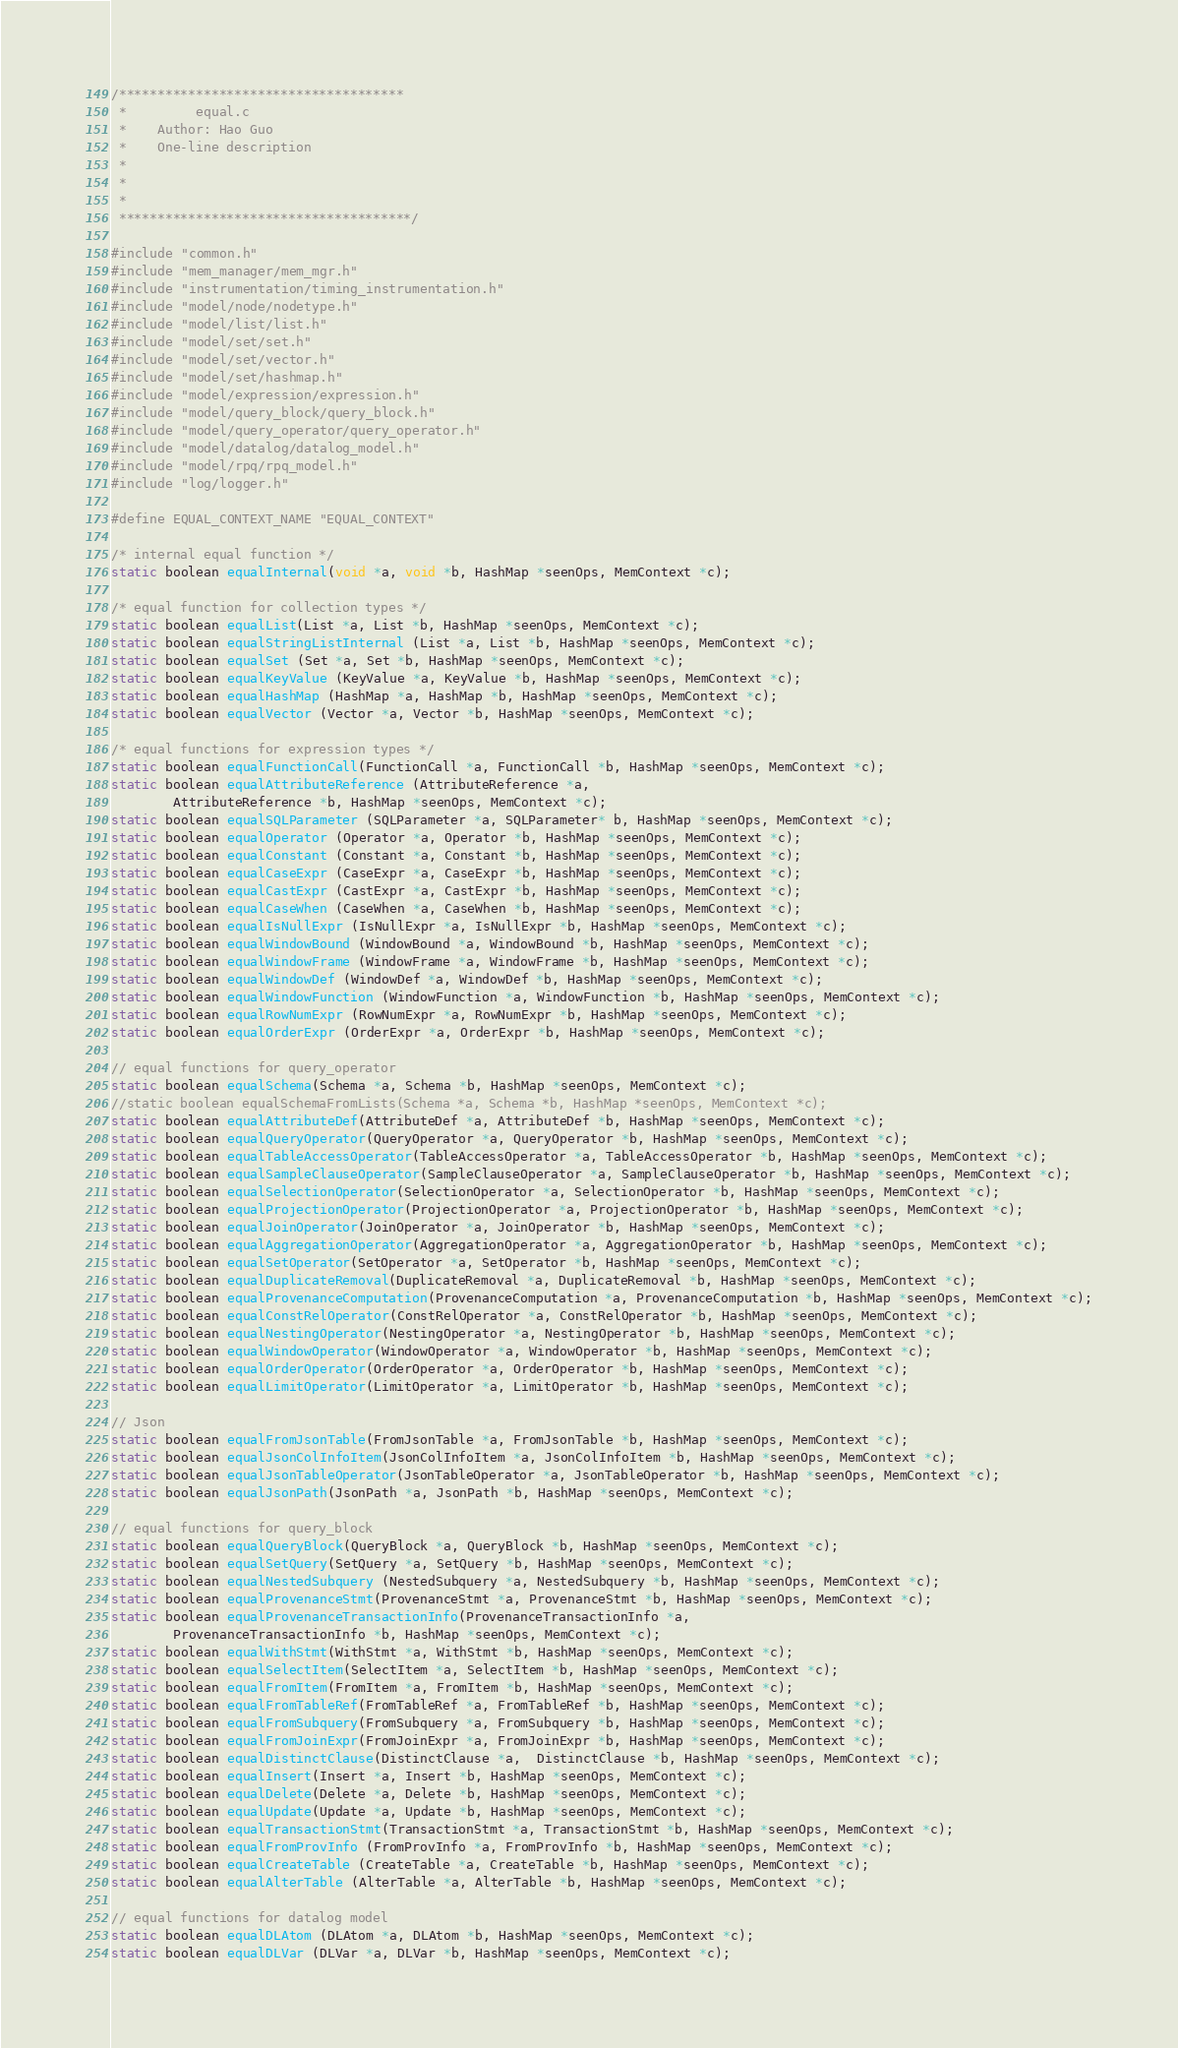Convert code to text. <code><loc_0><loc_0><loc_500><loc_500><_C_>/*************************************
 *         equal.c
 *    Author: Hao Guo
 *    One-line description
 *
 *
 *
 **************************************/

#include "common.h"
#include "mem_manager/mem_mgr.h"
#include "instrumentation/timing_instrumentation.h"
#include "model/node/nodetype.h"
#include "model/list/list.h"
#include "model/set/set.h"
#include "model/set/vector.h"
#include "model/set/hashmap.h"
#include "model/expression/expression.h"
#include "model/query_block/query_block.h"
#include "model/query_operator/query_operator.h"
#include "model/datalog/datalog_model.h"
#include "model/rpq/rpq_model.h"
#include "log/logger.h"

#define EQUAL_CONTEXT_NAME "EQUAL_CONTEXT"

/* internal equal function */
static boolean equalInternal(void *a, void *b, HashMap *seenOps, MemContext *c);

/* equal function for collection types */
static boolean equalList(List *a, List *b, HashMap *seenOps, MemContext *c);
static boolean equalStringListInternal (List *a, List *b, HashMap *seenOps, MemContext *c);
static boolean equalSet (Set *a, Set *b, HashMap *seenOps, MemContext *c);
static boolean equalKeyValue (KeyValue *a, KeyValue *b, HashMap *seenOps, MemContext *c);
static boolean equalHashMap (HashMap *a, HashMap *b, HashMap *seenOps, MemContext *c);
static boolean equalVector (Vector *a, Vector *b, HashMap *seenOps, MemContext *c);

/* equal functions for expression types */
static boolean equalFunctionCall(FunctionCall *a, FunctionCall *b, HashMap *seenOps, MemContext *c);
static boolean equalAttributeReference (AttributeReference *a,
        AttributeReference *b, HashMap *seenOps, MemContext *c);
static boolean equalSQLParameter (SQLParameter *a, SQLParameter* b, HashMap *seenOps, MemContext *c);
static boolean equalOperator (Operator *a, Operator *b, HashMap *seenOps, MemContext *c);
static boolean equalConstant (Constant *a, Constant *b, HashMap *seenOps, MemContext *c);
static boolean equalCaseExpr (CaseExpr *a, CaseExpr *b, HashMap *seenOps, MemContext *c);
static boolean equalCastExpr (CastExpr *a, CastExpr *b, HashMap *seenOps, MemContext *c);
static boolean equalCaseWhen (CaseWhen *a, CaseWhen *b, HashMap *seenOps, MemContext *c);
static boolean equalIsNullExpr (IsNullExpr *a, IsNullExpr *b, HashMap *seenOps, MemContext *c);
static boolean equalWindowBound (WindowBound *a, WindowBound *b, HashMap *seenOps, MemContext *c);
static boolean equalWindowFrame (WindowFrame *a, WindowFrame *b, HashMap *seenOps, MemContext *c);
static boolean equalWindowDef (WindowDef *a, WindowDef *b, HashMap *seenOps, MemContext *c);
static boolean equalWindowFunction (WindowFunction *a, WindowFunction *b, HashMap *seenOps, MemContext *c);
static boolean equalRowNumExpr (RowNumExpr *a, RowNumExpr *b, HashMap *seenOps, MemContext *c);
static boolean equalOrderExpr (OrderExpr *a, OrderExpr *b, HashMap *seenOps, MemContext *c);

// equal functions for query_operator
static boolean equalSchema(Schema *a, Schema *b, HashMap *seenOps, MemContext *c);
//static boolean equalSchemaFromLists(Schema *a, Schema *b, HashMap *seenOps, MemContext *c);
static boolean equalAttributeDef(AttributeDef *a, AttributeDef *b, HashMap *seenOps, MemContext *c);
static boolean equalQueryOperator(QueryOperator *a, QueryOperator *b, HashMap *seenOps, MemContext *c);
static boolean equalTableAccessOperator(TableAccessOperator *a, TableAccessOperator *b, HashMap *seenOps, MemContext *c);
static boolean equalSampleClauseOperator(SampleClauseOperator *a, SampleClauseOperator *b, HashMap *seenOps, MemContext *c);
static boolean equalSelectionOperator(SelectionOperator *a, SelectionOperator *b, HashMap *seenOps, MemContext *c);
static boolean equalProjectionOperator(ProjectionOperator *a, ProjectionOperator *b, HashMap *seenOps, MemContext *c);
static boolean equalJoinOperator(JoinOperator *a, JoinOperator *b, HashMap *seenOps, MemContext *c);
static boolean equalAggregationOperator(AggregationOperator *a, AggregationOperator *b, HashMap *seenOps, MemContext *c);
static boolean equalSetOperator(SetOperator *a, SetOperator *b, HashMap *seenOps, MemContext *c);
static boolean equalDuplicateRemoval(DuplicateRemoval *a, DuplicateRemoval *b, HashMap *seenOps, MemContext *c);
static boolean equalProvenanceComputation(ProvenanceComputation *a, ProvenanceComputation *b, HashMap *seenOps, MemContext *c);
static boolean equalConstRelOperator(ConstRelOperator *a, ConstRelOperator *b, HashMap *seenOps, MemContext *c);
static boolean equalNestingOperator(NestingOperator *a, NestingOperator *b, HashMap *seenOps, MemContext *c);
static boolean equalWindowOperator(WindowOperator *a, WindowOperator *b, HashMap *seenOps, MemContext *c);
static boolean equalOrderOperator(OrderOperator *a, OrderOperator *b, HashMap *seenOps, MemContext *c);
static boolean equalLimitOperator(LimitOperator *a, LimitOperator *b, HashMap *seenOps, MemContext *c);

// Json
static boolean equalFromJsonTable(FromJsonTable *a, FromJsonTable *b, HashMap *seenOps, MemContext *c);
static boolean equalJsonColInfoItem(JsonColInfoItem *a, JsonColInfoItem *b, HashMap *seenOps, MemContext *c);
static boolean equalJsonTableOperator(JsonTableOperator *a, JsonTableOperator *b, HashMap *seenOps, MemContext *c);
static boolean equalJsonPath(JsonPath *a, JsonPath *b, HashMap *seenOps, MemContext *c);

// equal functions for query_block
static boolean equalQueryBlock(QueryBlock *a, QueryBlock *b, HashMap *seenOps, MemContext *c);
static boolean equalSetQuery(SetQuery *a, SetQuery *b, HashMap *seenOps, MemContext *c);
static boolean equalNestedSubquery (NestedSubquery *a, NestedSubquery *b, HashMap *seenOps, MemContext *c);
static boolean equalProvenanceStmt(ProvenanceStmt *a, ProvenanceStmt *b, HashMap *seenOps, MemContext *c);
static boolean equalProvenanceTransactionInfo(ProvenanceTransactionInfo *a,
        ProvenanceTransactionInfo *b, HashMap *seenOps, MemContext *c);
static boolean equalWithStmt(WithStmt *a, WithStmt *b, HashMap *seenOps, MemContext *c);
static boolean equalSelectItem(SelectItem *a, SelectItem *b, HashMap *seenOps, MemContext *c);
static boolean equalFromItem(FromItem *a, FromItem *b, HashMap *seenOps, MemContext *c);
static boolean equalFromTableRef(FromTableRef *a, FromTableRef *b, HashMap *seenOps, MemContext *c);
static boolean equalFromSubquery(FromSubquery *a, FromSubquery *b, HashMap *seenOps, MemContext *c);
static boolean equalFromJoinExpr(FromJoinExpr *a, FromJoinExpr *b, HashMap *seenOps, MemContext *c);
static boolean equalDistinctClause(DistinctClause *a,  DistinctClause *b, HashMap *seenOps, MemContext *c);
static boolean equalInsert(Insert *a, Insert *b, HashMap *seenOps, MemContext *c);
static boolean equalDelete(Delete *a, Delete *b, HashMap *seenOps, MemContext *c);
static boolean equalUpdate(Update *a, Update *b, HashMap *seenOps, MemContext *c);
static boolean equalTransactionStmt(TransactionStmt *a, TransactionStmt *b, HashMap *seenOps, MemContext *c);
static boolean equalFromProvInfo (FromProvInfo *a, FromProvInfo *b, HashMap *seenOps, MemContext *c);
static boolean equalCreateTable (CreateTable *a, CreateTable *b, HashMap *seenOps, MemContext *c);
static boolean equalAlterTable (AlterTable *a, AlterTable *b, HashMap *seenOps, MemContext *c);

// equal functions for datalog model
static boolean equalDLAtom (DLAtom *a, DLAtom *b, HashMap *seenOps, MemContext *c);
static boolean equalDLVar (DLVar *a, DLVar *b, HashMap *seenOps, MemContext *c);</code> 